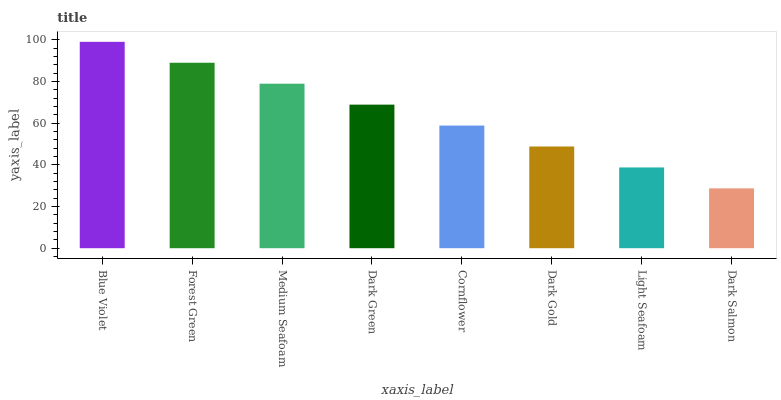Is Dark Salmon the minimum?
Answer yes or no. Yes. Is Blue Violet the maximum?
Answer yes or no. Yes. Is Forest Green the minimum?
Answer yes or no. No. Is Forest Green the maximum?
Answer yes or no. No. Is Blue Violet greater than Forest Green?
Answer yes or no. Yes. Is Forest Green less than Blue Violet?
Answer yes or no. Yes. Is Forest Green greater than Blue Violet?
Answer yes or no. No. Is Blue Violet less than Forest Green?
Answer yes or no. No. Is Dark Green the high median?
Answer yes or no. Yes. Is Cornflower the low median?
Answer yes or no. Yes. Is Dark Salmon the high median?
Answer yes or no. No. Is Medium Seafoam the low median?
Answer yes or no. No. 